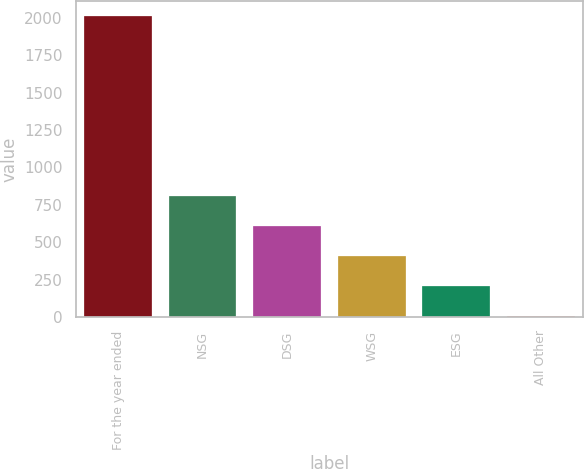Convert chart. <chart><loc_0><loc_0><loc_500><loc_500><bar_chart><fcel>For the year ended<fcel>NSG<fcel>DSG<fcel>WSG<fcel>ESG<fcel>All Other<nl><fcel>2012<fcel>807.8<fcel>607.1<fcel>406.4<fcel>205.7<fcel>5<nl></chart> 